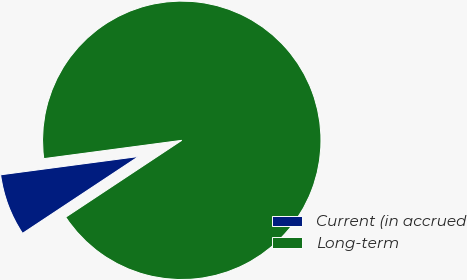<chart> <loc_0><loc_0><loc_500><loc_500><pie_chart><fcel>Current (in accrued<fcel>Long-term<nl><fcel>7.21%<fcel>92.79%<nl></chart> 